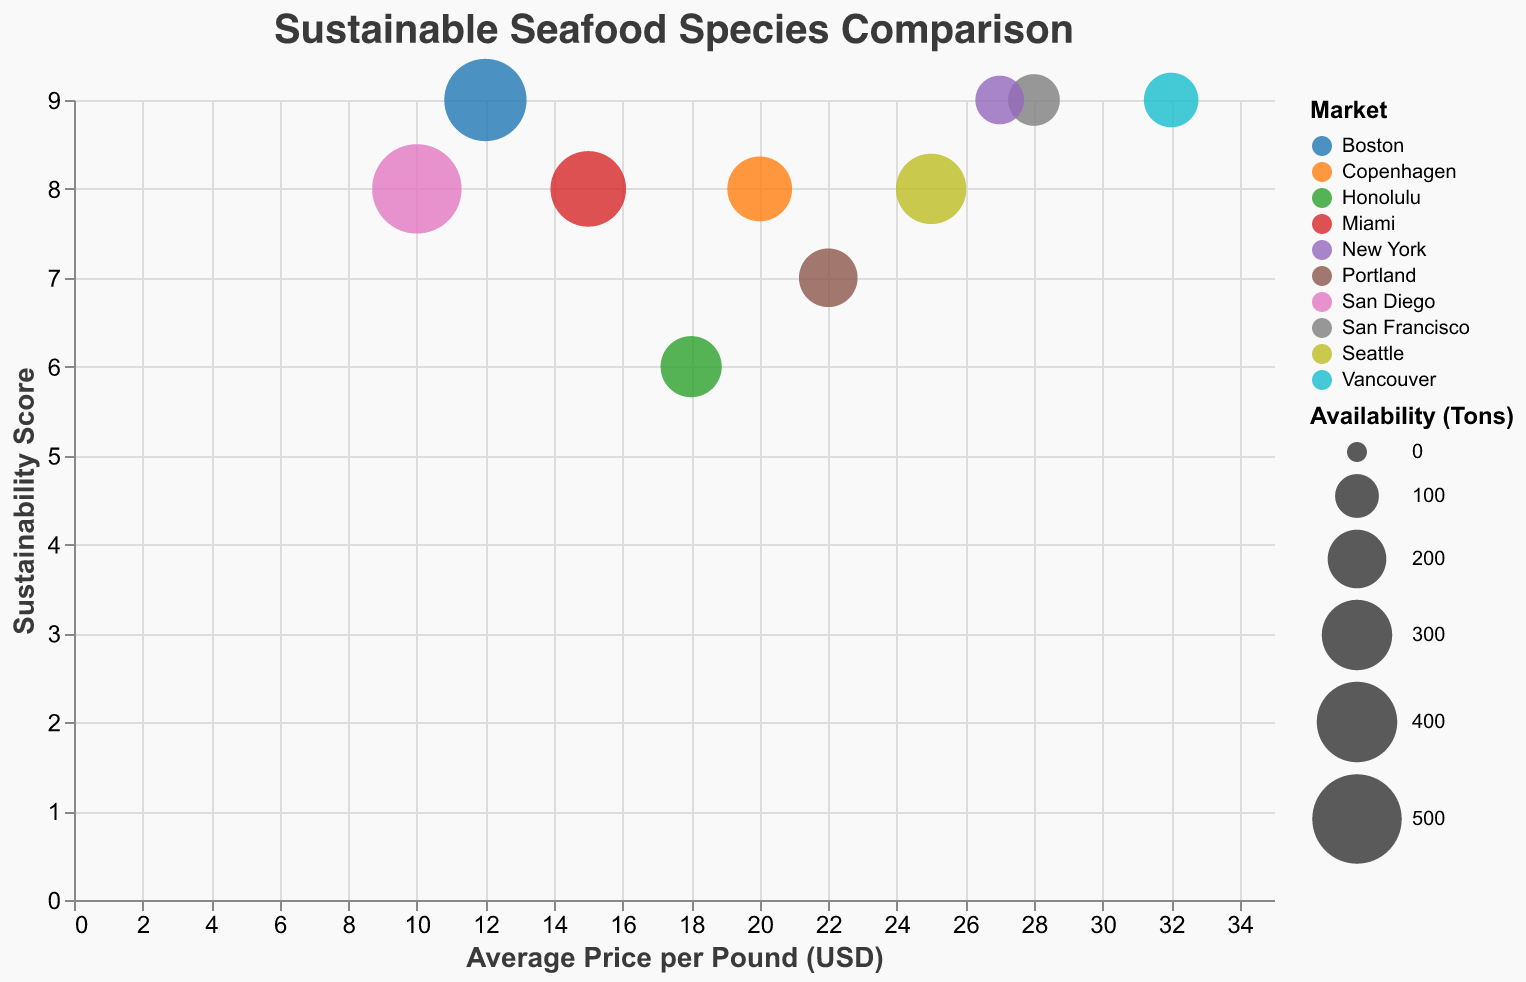How many species are represented in the figure? Count the number of unique species names in the data points displayed on the chart.
Answer: 10 Which seafood species has the lowest average price per pound, and what is that price? Look at the x-axis (Average Price per Pound) and find the leftmost data point, then refer to its tooltip information.
Answer: Pacific Sardine, 10 USD Which market has the highest sustainability score for its seafood? Find the data point with the highest value on the y-axis (Sustainability Score) and check its corresponding tooltip information for the market name.
Answer: Boston What is the average sustainability score for seafood species priced above 25 USD per pound? Identify data points with an average price above 25 USD, take their sustainability scores and calculate their average: (9 + 9 + 9)/3 = 9
Answer: 9 Which seafood species has the highest availability and what is its sustainability score? Find the data point with the largest bubble size and refer to its tooltip information for availability and sustainability score.
Answer: Pacific Sardine, 8 Which market features a seafood species with both high sustainability (9) and high average price (32 USD)? Cross-reference the y-axis (Sustainability Score) and x-axis (Average Price) to find the data point matching these values, then check its market in the tooltip.
Answer: Vancouver If you sum the availabilities of seafood species with a sustainability score of 8, what is the total? Identify data points with a sustainability score of 8, sum their availabilities: 300 + 500 + 350 + 250
Answer: 1400 How does the price of Wild Alaskan Salmon compare to that of Pacific Halibut? Compare the x-axis positions (Average Price per Pound) of Wild Alaskan Salmon and Pacific Halibut to determine which is higher.
Answer: Wild Alaskan Salmon is higher What is the difference in sustainability scores between the most and least sustainable species? Identify the highest (9) and lowest (6) sustainability scores from the y-axis and calculate the difference: 9 - 6
Answer: 3 Which species is shown in a red-colored bubble, and what market does it come from? Spot the red-colored bubble and refer to its tooltip information for species and market details.
Answer: Northern Prawn, Copenhagen 